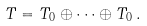<formula> <loc_0><loc_0><loc_500><loc_500>T = T _ { 0 } \oplus \cdots \oplus T _ { 0 } \, .</formula> 